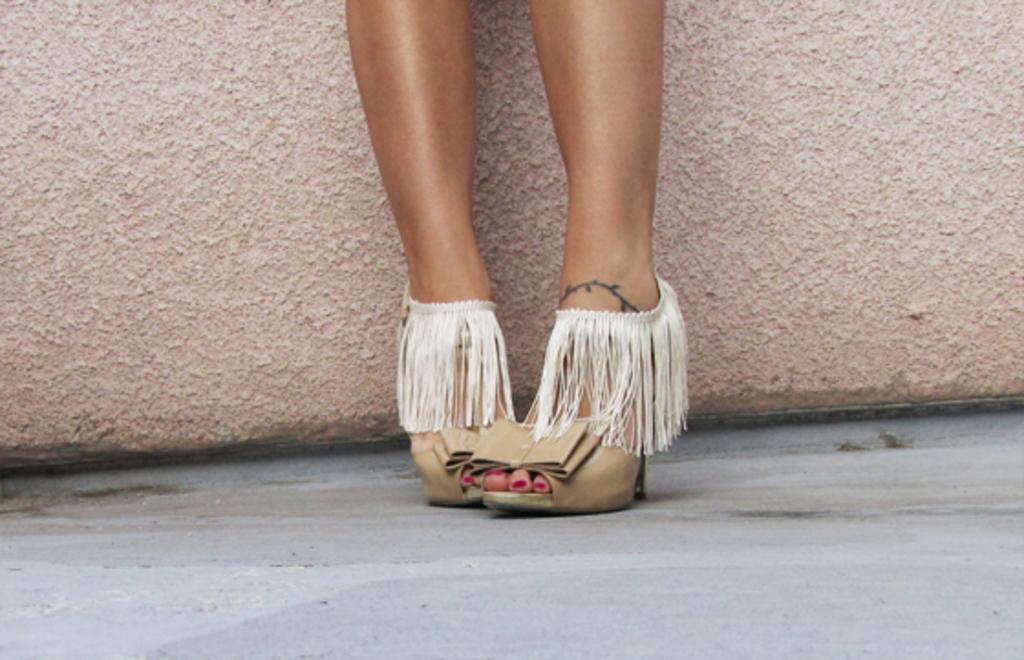How would you summarize this image in a sentence or two? In this picture we can see the close view of the girl's legs with sandals. Behind there is a brown texture wall. 